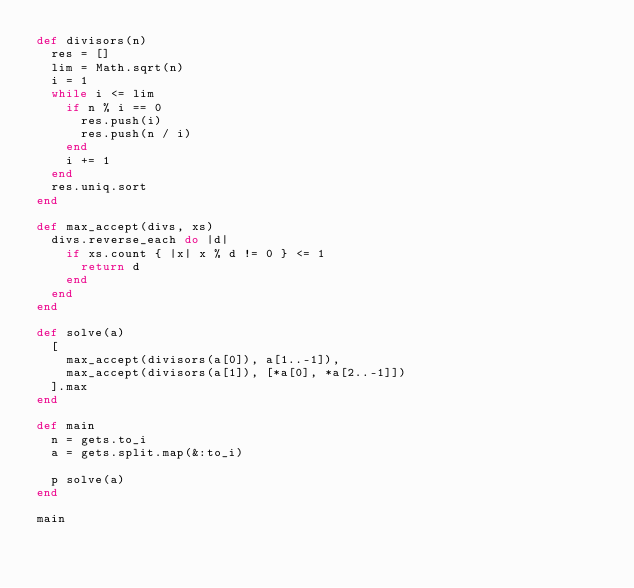<code> <loc_0><loc_0><loc_500><loc_500><_Ruby_>def divisors(n)
  res = []
  lim = Math.sqrt(n)
  i = 1
  while i <= lim
    if n % i == 0
      res.push(i)
      res.push(n / i)
    end
    i += 1
  end
  res.uniq.sort
end

def max_accept(divs, xs)
  divs.reverse_each do |d|
    if xs.count { |x| x % d != 0 } <= 1
      return d
    end
  end
end

def solve(a)
  [
    max_accept(divisors(a[0]), a[1..-1]),
    max_accept(divisors(a[1]), [*a[0], *a[2..-1]])
  ].max
end

def main
  n = gets.to_i
  a = gets.split.map(&:to_i)

  p solve(a)
end

main
</code> 